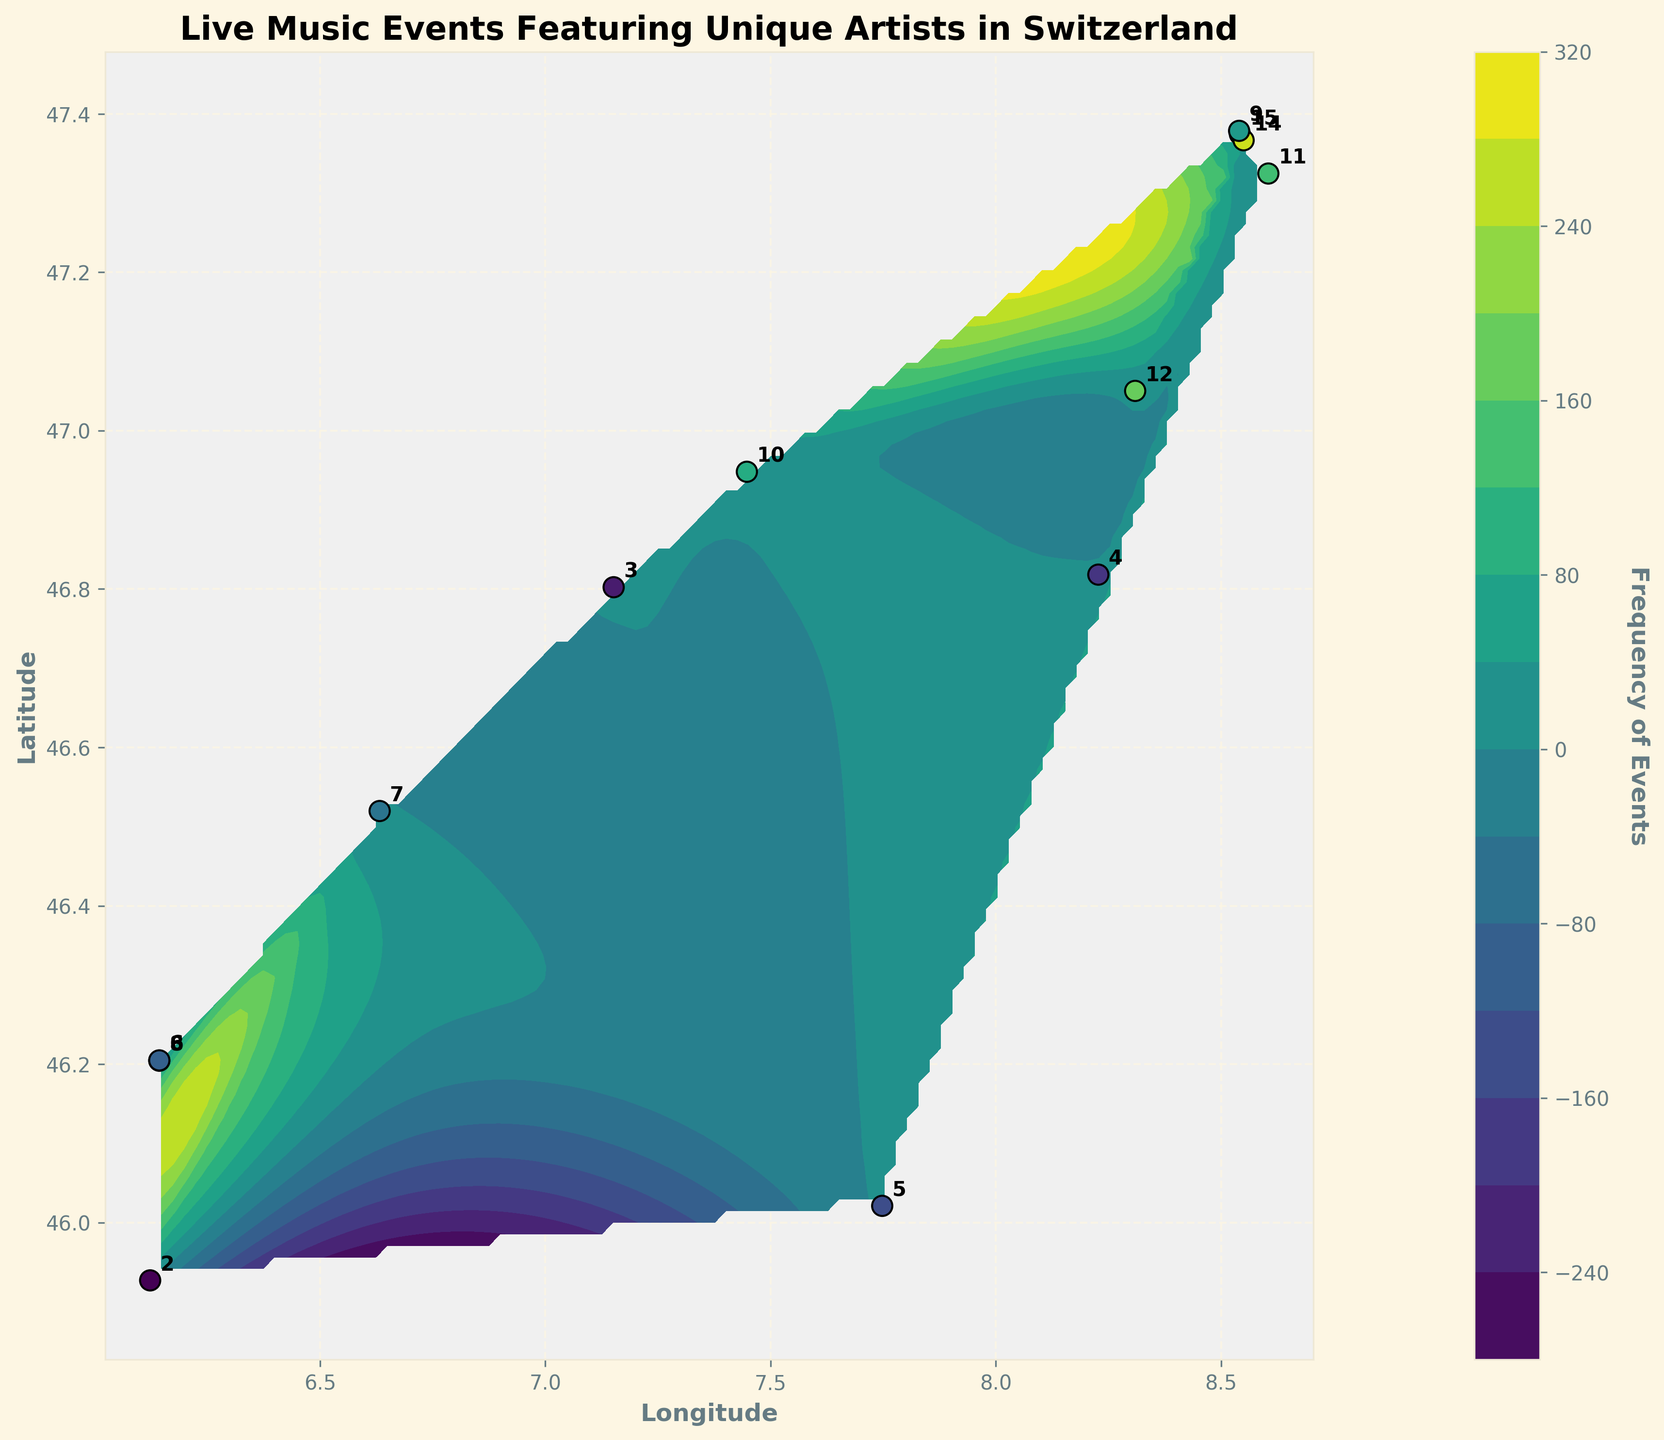What is the title of the figure? The title of the figure is usually placed at the top of the plot and describes its content. In this case, reading the top of the plot reveals the title.
Answer: Live Music Events Featuring Unique Artists in Switzerland How many live music events are held in Zurich (47.3744, 8.5418)? To find this, locate the point on the plot at (47.3744, 8.5418) and read the annotated number beside it.
Answer: 15 Which city has the lowest frequency of live music events? Identify the smallest annotated number on the plot, and then locate its corresponding coordinates.
Answer: (45.9270, 6.1229) with 2 events What is the average frequency of live music events in the plotted cities? Sum all the frequencies and divide by the number of cities: (15+10+8+12+7+5+3+14+6+9+4+11+2) / 13 = 106 / 13 = 8.15
Answer: 8.15 Which city has a higher frequency of events: Geneva (46.2044, 6.1432) or Lausanne (46.5197, 6.6323)? Compare the annotated numbers for the points corresponding to Geneva and Lausanne.
Answer: Geneva (8) vs Lausanne (7); Geneva has more events What is the color associated with a frequency of 10 events? Inspect the colorbar for the shading that corresponds to the frequency value of 10 and identify this specific color in the contour plot.
Answer: Mid-range green Are there more events in the north or south of Switzerland? Compare the sum of frequencies for northern locations (e.g., latitudes closer to 47) vs. southern ones (latitudes closer to 46).
Answer: North has more events What is the range of frequencies shown in the color bar? Identify the minimum and maximum values displayed on the color bar.
Answer: 2 to 15 Which location has the highest frequency of music events and what is its frequency? Find the point with the highest annotated number on the plot and note its coordinates and value.
Answer: Zurich (47.3744, 8.5418) with 15 events What is the overall trend in the geographic distribution of live music events? Examine the gradient and patterns within the contour plot, looking for areas of high and low event frequencies.
Answer: Higher frequencies in northern regions, lower in southern regions 